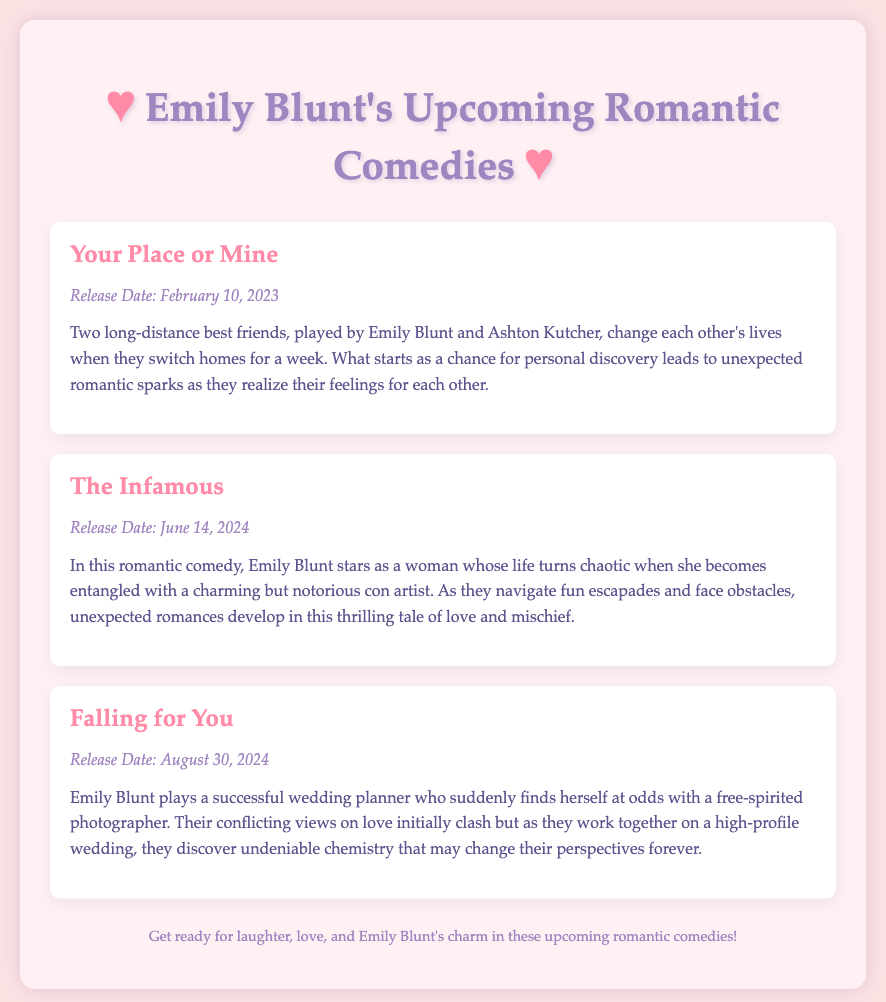What is the title of Emily Blunt's romance that releases on February 10, 2023? The title is specifically mentioned in the document as "Your Place or Mine."
Answer: Your Place or Mine What is the release date for "The Infamous"? The release date is clearly stated in the document as June 14, 2024.
Answer: June 14, 2024 Who co-stars with Emily Blunt in "Your Place or Mine"? The document directly lists Ashton Kutcher as the co-star.
Answer: Ashton Kutcher What type of character does Emily Blunt play in "Falling for You"? The document describes her character as a successful wedding planner.
Answer: Wedding planner In which romantic comedy do Emily Blunt and a con artist navigate fun escapades? This situation is described in "The Infamous."
Answer: The Infamous What is the primary conflict in "Falling for You"? The plot overview discusses conflicting views on love between the two main characters.
Answer: Conflicting views on love How many upcoming romantic comedies starring Emily Blunt are mentioned? The document lists a total of three upcoming films.
Answer: Three What theme do all these upcoming movies center around? The overall theme connects to love and romance in comedic settings.
Answer: Love and romance 